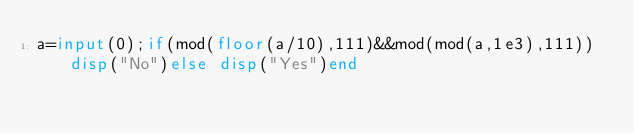<code> <loc_0><loc_0><loc_500><loc_500><_Octave_>a=input(0);if(mod(floor(a/10),111)&&mod(mod(a,1e3),111))disp("No")else disp("Yes")end</code> 